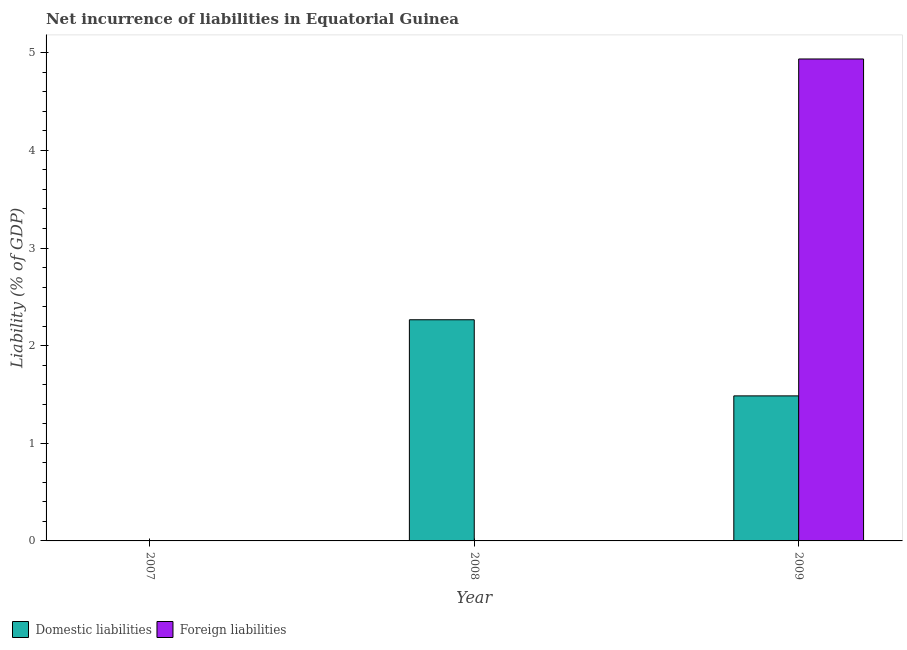How many different coloured bars are there?
Provide a succinct answer. 2. Are the number of bars on each tick of the X-axis equal?
Provide a short and direct response. No. How many bars are there on the 1st tick from the right?
Your answer should be compact. 2. In how many cases, is the number of bars for a given year not equal to the number of legend labels?
Provide a short and direct response. 2. Across all years, what is the maximum incurrence of domestic liabilities?
Your answer should be compact. 2.27. In which year was the incurrence of domestic liabilities maximum?
Provide a succinct answer. 2008. What is the total incurrence of foreign liabilities in the graph?
Ensure brevity in your answer.  4.94. What is the difference between the incurrence of domestic liabilities in 2008 and that in 2009?
Offer a terse response. 0.78. What is the difference between the incurrence of domestic liabilities in 2009 and the incurrence of foreign liabilities in 2008?
Give a very brief answer. -0.78. What is the average incurrence of domestic liabilities per year?
Your answer should be compact. 1.25. What is the ratio of the incurrence of domestic liabilities in 2008 to that in 2009?
Offer a terse response. 1.52. Is the difference between the incurrence of domestic liabilities in 2008 and 2009 greater than the difference between the incurrence of foreign liabilities in 2008 and 2009?
Offer a very short reply. No. What is the difference between the highest and the lowest incurrence of domestic liabilities?
Your response must be concise. 2.27. In how many years, is the incurrence of domestic liabilities greater than the average incurrence of domestic liabilities taken over all years?
Keep it short and to the point. 2. Is the sum of the incurrence of domestic liabilities in 2008 and 2009 greater than the maximum incurrence of foreign liabilities across all years?
Provide a short and direct response. Yes. How many bars are there?
Ensure brevity in your answer.  3. What is the difference between two consecutive major ticks on the Y-axis?
Your answer should be compact. 1. Does the graph contain grids?
Give a very brief answer. No. Where does the legend appear in the graph?
Your response must be concise. Bottom left. How many legend labels are there?
Your answer should be compact. 2. How are the legend labels stacked?
Your answer should be very brief. Horizontal. What is the title of the graph?
Ensure brevity in your answer.  Net incurrence of liabilities in Equatorial Guinea. Does "Net National savings" appear as one of the legend labels in the graph?
Make the answer very short. No. What is the label or title of the X-axis?
Offer a very short reply. Year. What is the label or title of the Y-axis?
Offer a very short reply. Liability (% of GDP). What is the Liability (% of GDP) of Domestic liabilities in 2008?
Give a very brief answer. 2.27. What is the Liability (% of GDP) in Domestic liabilities in 2009?
Offer a terse response. 1.49. What is the Liability (% of GDP) of Foreign liabilities in 2009?
Offer a very short reply. 4.94. Across all years, what is the maximum Liability (% of GDP) in Domestic liabilities?
Your answer should be very brief. 2.27. Across all years, what is the maximum Liability (% of GDP) in Foreign liabilities?
Make the answer very short. 4.94. Across all years, what is the minimum Liability (% of GDP) of Domestic liabilities?
Provide a succinct answer. 0. Across all years, what is the minimum Liability (% of GDP) in Foreign liabilities?
Provide a succinct answer. 0. What is the total Liability (% of GDP) of Domestic liabilities in the graph?
Provide a short and direct response. 3.75. What is the total Liability (% of GDP) in Foreign liabilities in the graph?
Offer a very short reply. 4.94. What is the difference between the Liability (% of GDP) in Domestic liabilities in 2008 and that in 2009?
Make the answer very short. 0.78. What is the difference between the Liability (% of GDP) in Domestic liabilities in 2008 and the Liability (% of GDP) in Foreign liabilities in 2009?
Give a very brief answer. -2.67. What is the average Liability (% of GDP) of Domestic liabilities per year?
Your answer should be very brief. 1.25. What is the average Liability (% of GDP) of Foreign liabilities per year?
Provide a short and direct response. 1.65. In the year 2009, what is the difference between the Liability (% of GDP) in Domestic liabilities and Liability (% of GDP) in Foreign liabilities?
Give a very brief answer. -3.45. What is the ratio of the Liability (% of GDP) in Domestic liabilities in 2008 to that in 2009?
Your response must be concise. 1.52. What is the difference between the highest and the lowest Liability (% of GDP) of Domestic liabilities?
Make the answer very short. 2.27. What is the difference between the highest and the lowest Liability (% of GDP) in Foreign liabilities?
Provide a short and direct response. 4.94. 